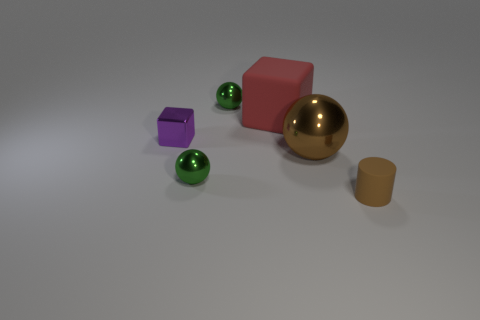What shape is the metal thing that is the same color as the small rubber cylinder?
Your response must be concise. Sphere. There is a block that is right of the tiny purple shiny object in front of the metal thing behind the purple thing; what is its size?
Keep it short and to the point. Large. There is a tiny green thing in front of the tiny green metal object that is behind the big brown thing; what shape is it?
Your answer should be very brief. Sphere. There is a small object that is to the right of the big red block; does it have the same color as the big shiny ball?
Your answer should be compact. Yes. What color is the small thing that is in front of the small block and behind the small rubber cylinder?
Keep it short and to the point. Green. Is there a thing that has the same material as the big block?
Your answer should be very brief. Yes. What is the size of the matte cube?
Keep it short and to the point. Large. There is a rubber object to the left of the large object to the right of the red thing; what is its size?
Provide a succinct answer. Large. What material is the large red object that is the same shape as the tiny purple shiny thing?
Provide a short and direct response. Rubber. How many red blocks are there?
Offer a terse response. 1. 